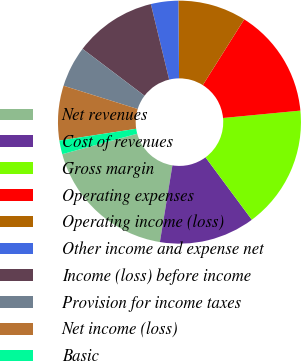Convert chart. <chart><loc_0><loc_0><loc_500><loc_500><pie_chart><fcel>Net revenues<fcel>Cost of revenues<fcel>Gross margin<fcel>Operating expenses<fcel>Operating income (loss)<fcel>Other income and expense net<fcel>Income (loss) before income<fcel>Provision for income taxes<fcel>Net income (loss)<fcel>Basic<nl><fcel>18.18%<fcel>12.73%<fcel>16.36%<fcel>14.54%<fcel>9.09%<fcel>3.64%<fcel>10.91%<fcel>5.46%<fcel>7.27%<fcel>1.82%<nl></chart> 